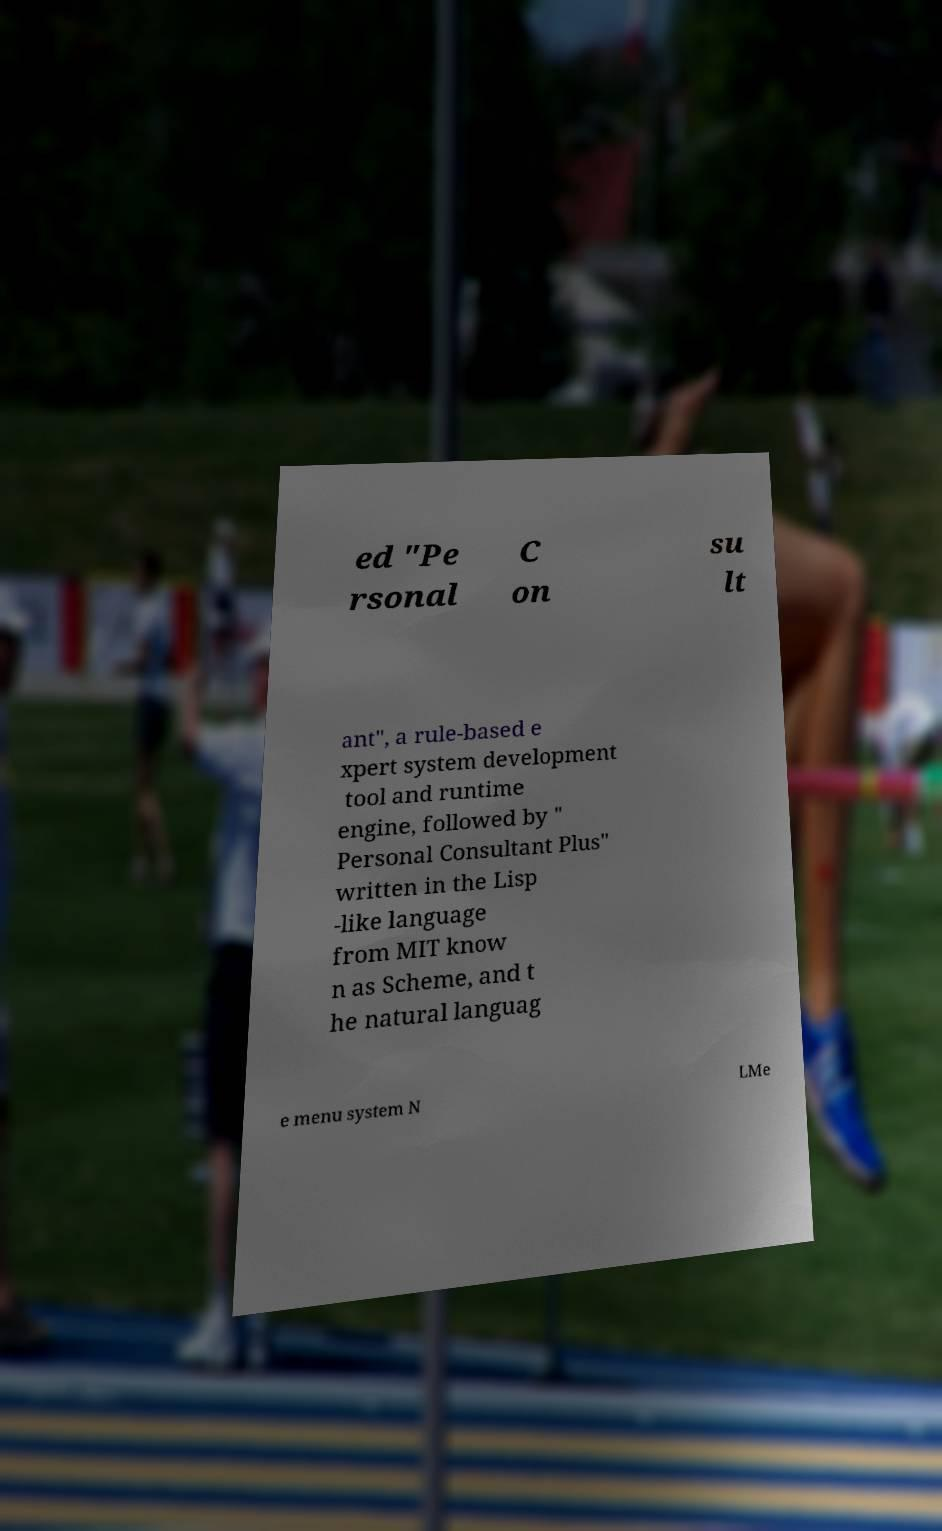I need the written content from this picture converted into text. Can you do that? ed "Pe rsonal C on su lt ant", a rule-based e xpert system development tool and runtime engine, followed by " Personal Consultant Plus" written in the Lisp -like language from MIT know n as Scheme, and t he natural languag e menu system N LMe 